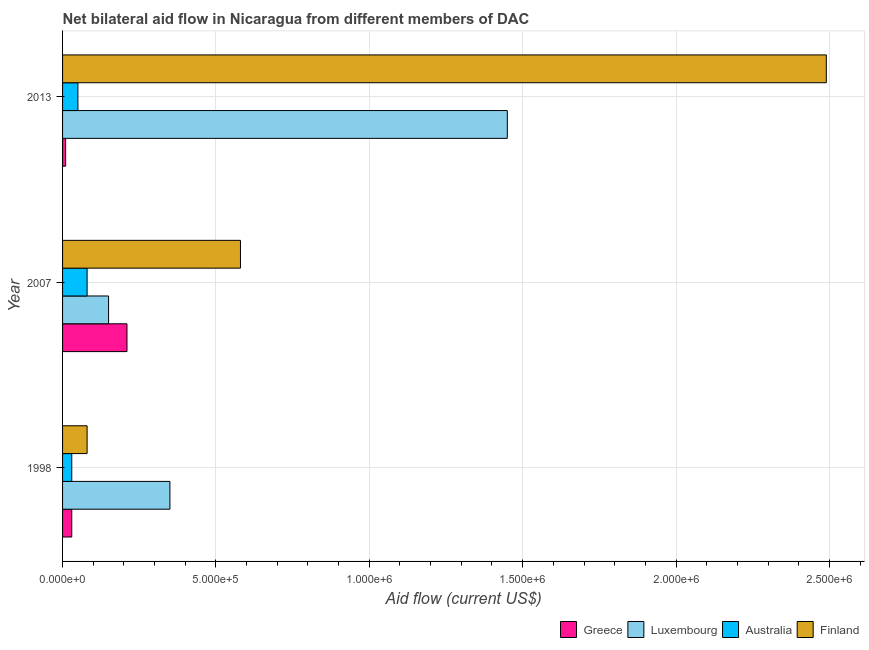How many different coloured bars are there?
Your answer should be very brief. 4. How many groups of bars are there?
Offer a very short reply. 3. Are the number of bars on each tick of the Y-axis equal?
Make the answer very short. Yes. What is the label of the 3rd group of bars from the top?
Offer a very short reply. 1998. What is the amount of aid given by australia in 2013?
Make the answer very short. 5.00e+04. Across all years, what is the maximum amount of aid given by finland?
Give a very brief answer. 2.49e+06. Across all years, what is the minimum amount of aid given by luxembourg?
Make the answer very short. 1.50e+05. In which year was the amount of aid given by australia minimum?
Your answer should be very brief. 1998. What is the total amount of aid given by luxembourg in the graph?
Make the answer very short. 1.95e+06. What is the difference between the amount of aid given by luxembourg in 2007 and that in 2013?
Provide a succinct answer. -1.30e+06. What is the difference between the amount of aid given by luxembourg in 1998 and the amount of aid given by greece in 2007?
Make the answer very short. 1.40e+05. What is the average amount of aid given by australia per year?
Your answer should be compact. 5.33e+04. In the year 2013, what is the difference between the amount of aid given by luxembourg and amount of aid given by finland?
Your answer should be compact. -1.04e+06. What is the ratio of the amount of aid given by greece in 1998 to that in 2007?
Your response must be concise. 0.14. Is the difference between the amount of aid given by luxembourg in 1998 and 2007 greater than the difference between the amount of aid given by finland in 1998 and 2007?
Make the answer very short. Yes. What is the difference between the highest and the second highest amount of aid given by luxembourg?
Offer a very short reply. 1.10e+06. What is the difference between the highest and the lowest amount of aid given by australia?
Ensure brevity in your answer.  5.00e+04. In how many years, is the amount of aid given by luxembourg greater than the average amount of aid given by luxembourg taken over all years?
Your answer should be compact. 1. Is the sum of the amount of aid given by greece in 1998 and 2007 greater than the maximum amount of aid given by australia across all years?
Make the answer very short. Yes. Is it the case that in every year, the sum of the amount of aid given by greece and amount of aid given by luxembourg is greater than the amount of aid given by australia?
Make the answer very short. Yes. How many bars are there?
Provide a succinct answer. 12. Are all the bars in the graph horizontal?
Provide a short and direct response. Yes. Are the values on the major ticks of X-axis written in scientific E-notation?
Your answer should be compact. Yes. Does the graph contain any zero values?
Keep it short and to the point. No. Does the graph contain grids?
Keep it short and to the point. Yes. What is the title of the graph?
Offer a very short reply. Net bilateral aid flow in Nicaragua from different members of DAC. Does "International Monetary Fund" appear as one of the legend labels in the graph?
Your response must be concise. No. What is the label or title of the X-axis?
Keep it short and to the point. Aid flow (current US$). What is the Aid flow (current US$) in Greece in 1998?
Your answer should be very brief. 3.00e+04. What is the Aid flow (current US$) in Luxembourg in 2007?
Make the answer very short. 1.50e+05. What is the Aid flow (current US$) of Australia in 2007?
Your answer should be very brief. 8.00e+04. What is the Aid flow (current US$) of Finland in 2007?
Give a very brief answer. 5.80e+05. What is the Aid flow (current US$) in Greece in 2013?
Offer a very short reply. 10000. What is the Aid flow (current US$) in Luxembourg in 2013?
Offer a terse response. 1.45e+06. What is the Aid flow (current US$) of Australia in 2013?
Your answer should be compact. 5.00e+04. What is the Aid flow (current US$) of Finland in 2013?
Provide a short and direct response. 2.49e+06. Across all years, what is the maximum Aid flow (current US$) of Luxembourg?
Your response must be concise. 1.45e+06. Across all years, what is the maximum Aid flow (current US$) of Finland?
Your answer should be very brief. 2.49e+06. Across all years, what is the minimum Aid flow (current US$) of Greece?
Ensure brevity in your answer.  10000. Across all years, what is the minimum Aid flow (current US$) in Australia?
Provide a short and direct response. 3.00e+04. What is the total Aid flow (current US$) of Greece in the graph?
Your answer should be very brief. 2.50e+05. What is the total Aid flow (current US$) of Luxembourg in the graph?
Provide a succinct answer. 1.95e+06. What is the total Aid flow (current US$) in Finland in the graph?
Offer a terse response. 3.15e+06. What is the difference between the Aid flow (current US$) in Australia in 1998 and that in 2007?
Offer a terse response. -5.00e+04. What is the difference between the Aid flow (current US$) in Finland in 1998 and that in 2007?
Offer a terse response. -5.00e+05. What is the difference between the Aid flow (current US$) of Greece in 1998 and that in 2013?
Make the answer very short. 2.00e+04. What is the difference between the Aid flow (current US$) of Luxembourg in 1998 and that in 2013?
Ensure brevity in your answer.  -1.10e+06. What is the difference between the Aid flow (current US$) of Finland in 1998 and that in 2013?
Provide a succinct answer. -2.41e+06. What is the difference between the Aid flow (current US$) of Greece in 2007 and that in 2013?
Give a very brief answer. 2.00e+05. What is the difference between the Aid flow (current US$) in Luxembourg in 2007 and that in 2013?
Ensure brevity in your answer.  -1.30e+06. What is the difference between the Aid flow (current US$) of Finland in 2007 and that in 2013?
Offer a terse response. -1.91e+06. What is the difference between the Aid flow (current US$) in Greece in 1998 and the Aid flow (current US$) in Luxembourg in 2007?
Your response must be concise. -1.20e+05. What is the difference between the Aid flow (current US$) in Greece in 1998 and the Aid flow (current US$) in Finland in 2007?
Make the answer very short. -5.50e+05. What is the difference between the Aid flow (current US$) in Australia in 1998 and the Aid flow (current US$) in Finland in 2007?
Your answer should be very brief. -5.50e+05. What is the difference between the Aid flow (current US$) of Greece in 1998 and the Aid flow (current US$) of Luxembourg in 2013?
Your answer should be very brief. -1.42e+06. What is the difference between the Aid flow (current US$) in Greece in 1998 and the Aid flow (current US$) in Finland in 2013?
Ensure brevity in your answer.  -2.46e+06. What is the difference between the Aid flow (current US$) of Luxembourg in 1998 and the Aid flow (current US$) of Finland in 2013?
Keep it short and to the point. -2.14e+06. What is the difference between the Aid flow (current US$) in Australia in 1998 and the Aid flow (current US$) in Finland in 2013?
Your response must be concise. -2.46e+06. What is the difference between the Aid flow (current US$) of Greece in 2007 and the Aid flow (current US$) of Luxembourg in 2013?
Your answer should be compact. -1.24e+06. What is the difference between the Aid flow (current US$) in Greece in 2007 and the Aid flow (current US$) in Finland in 2013?
Make the answer very short. -2.28e+06. What is the difference between the Aid flow (current US$) of Luxembourg in 2007 and the Aid flow (current US$) of Finland in 2013?
Keep it short and to the point. -2.34e+06. What is the difference between the Aid flow (current US$) in Australia in 2007 and the Aid flow (current US$) in Finland in 2013?
Your answer should be compact. -2.41e+06. What is the average Aid flow (current US$) of Greece per year?
Your answer should be compact. 8.33e+04. What is the average Aid flow (current US$) in Luxembourg per year?
Make the answer very short. 6.50e+05. What is the average Aid flow (current US$) of Australia per year?
Your answer should be compact. 5.33e+04. What is the average Aid flow (current US$) of Finland per year?
Your response must be concise. 1.05e+06. In the year 1998, what is the difference between the Aid flow (current US$) in Greece and Aid flow (current US$) in Luxembourg?
Offer a very short reply. -3.20e+05. In the year 1998, what is the difference between the Aid flow (current US$) of Greece and Aid flow (current US$) of Australia?
Provide a short and direct response. 0. In the year 1998, what is the difference between the Aid flow (current US$) of Luxembourg and Aid flow (current US$) of Finland?
Ensure brevity in your answer.  2.70e+05. In the year 2007, what is the difference between the Aid flow (current US$) in Greece and Aid flow (current US$) in Luxembourg?
Provide a short and direct response. 6.00e+04. In the year 2007, what is the difference between the Aid flow (current US$) in Greece and Aid flow (current US$) in Australia?
Your answer should be compact. 1.30e+05. In the year 2007, what is the difference between the Aid flow (current US$) in Greece and Aid flow (current US$) in Finland?
Give a very brief answer. -3.70e+05. In the year 2007, what is the difference between the Aid flow (current US$) in Luxembourg and Aid flow (current US$) in Australia?
Your answer should be very brief. 7.00e+04. In the year 2007, what is the difference between the Aid flow (current US$) of Luxembourg and Aid flow (current US$) of Finland?
Your response must be concise. -4.30e+05. In the year 2007, what is the difference between the Aid flow (current US$) of Australia and Aid flow (current US$) of Finland?
Your response must be concise. -5.00e+05. In the year 2013, what is the difference between the Aid flow (current US$) of Greece and Aid flow (current US$) of Luxembourg?
Make the answer very short. -1.44e+06. In the year 2013, what is the difference between the Aid flow (current US$) of Greece and Aid flow (current US$) of Australia?
Provide a short and direct response. -4.00e+04. In the year 2013, what is the difference between the Aid flow (current US$) in Greece and Aid flow (current US$) in Finland?
Your response must be concise. -2.48e+06. In the year 2013, what is the difference between the Aid flow (current US$) in Luxembourg and Aid flow (current US$) in Australia?
Your response must be concise. 1.40e+06. In the year 2013, what is the difference between the Aid flow (current US$) of Luxembourg and Aid flow (current US$) of Finland?
Your answer should be very brief. -1.04e+06. In the year 2013, what is the difference between the Aid flow (current US$) in Australia and Aid flow (current US$) in Finland?
Make the answer very short. -2.44e+06. What is the ratio of the Aid flow (current US$) in Greece in 1998 to that in 2007?
Offer a terse response. 0.14. What is the ratio of the Aid flow (current US$) in Luxembourg in 1998 to that in 2007?
Your response must be concise. 2.33. What is the ratio of the Aid flow (current US$) of Finland in 1998 to that in 2007?
Offer a very short reply. 0.14. What is the ratio of the Aid flow (current US$) in Luxembourg in 1998 to that in 2013?
Your response must be concise. 0.24. What is the ratio of the Aid flow (current US$) in Australia in 1998 to that in 2013?
Keep it short and to the point. 0.6. What is the ratio of the Aid flow (current US$) in Finland in 1998 to that in 2013?
Your answer should be compact. 0.03. What is the ratio of the Aid flow (current US$) of Greece in 2007 to that in 2013?
Your answer should be compact. 21. What is the ratio of the Aid flow (current US$) of Luxembourg in 2007 to that in 2013?
Give a very brief answer. 0.1. What is the ratio of the Aid flow (current US$) of Finland in 2007 to that in 2013?
Offer a very short reply. 0.23. What is the difference between the highest and the second highest Aid flow (current US$) in Greece?
Your answer should be very brief. 1.80e+05. What is the difference between the highest and the second highest Aid flow (current US$) of Luxembourg?
Ensure brevity in your answer.  1.10e+06. What is the difference between the highest and the second highest Aid flow (current US$) of Finland?
Provide a succinct answer. 1.91e+06. What is the difference between the highest and the lowest Aid flow (current US$) in Luxembourg?
Your answer should be compact. 1.30e+06. What is the difference between the highest and the lowest Aid flow (current US$) in Finland?
Keep it short and to the point. 2.41e+06. 